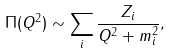<formula> <loc_0><loc_0><loc_500><loc_500>\Pi ( Q ^ { 2 } ) \sim \sum _ { i } \frac { Z _ { i } } { Q ^ { 2 } + m _ { i } ^ { 2 } } ,</formula> 